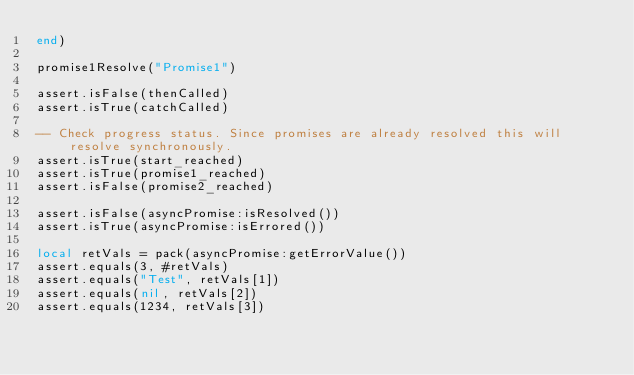Convert code to text. <code><loc_0><loc_0><loc_500><loc_500><_Lua_>end)

promise1Resolve("Promise1")

assert.isFalse(thenCalled)
assert.isTrue(catchCalled)

-- Check progress status. Since promises are already resolved this will resolve synchronously.
assert.isTrue(start_reached)
assert.isTrue(promise1_reached)
assert.isFalse(promise2_reached)

assert.isFalse(asyncPromise:isResolved())
assert.isTrue(asyncPromise:isErrored())

local retVals = pack(asyncPromise:getErrorValue())
assert.equals(3, #retVals)
assert.equals("Test", retVals[1])
assert.equals(nil, retVals[2])
assert.equals(1234, retVals[3])
</code> 